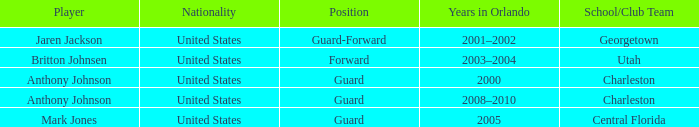Who was the Player that had the Position, guard-forward? Jaren Jackson. 